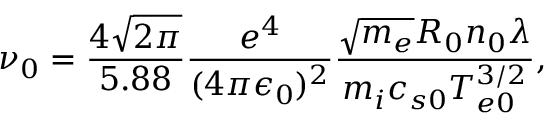Convert formula to latex. <formula><loc_0><loc_0><loc_500><loc_500>\nu _ { 0 } = \frac { 4 \sqrt { 2 \pi } } { 5 . 8 8 } \frac { e ^ { 4 } } { ( 4 \pi \epsilon _ { 0 } ) ^ { 2 } } \frac { \sqrt { m _ { e } } R _ { 0 } n _ { 0 } \lambda } { m _ { i } c _ { s 0 } T _ { e 0 } ^ { 3 / 2 } } ,</formula> 